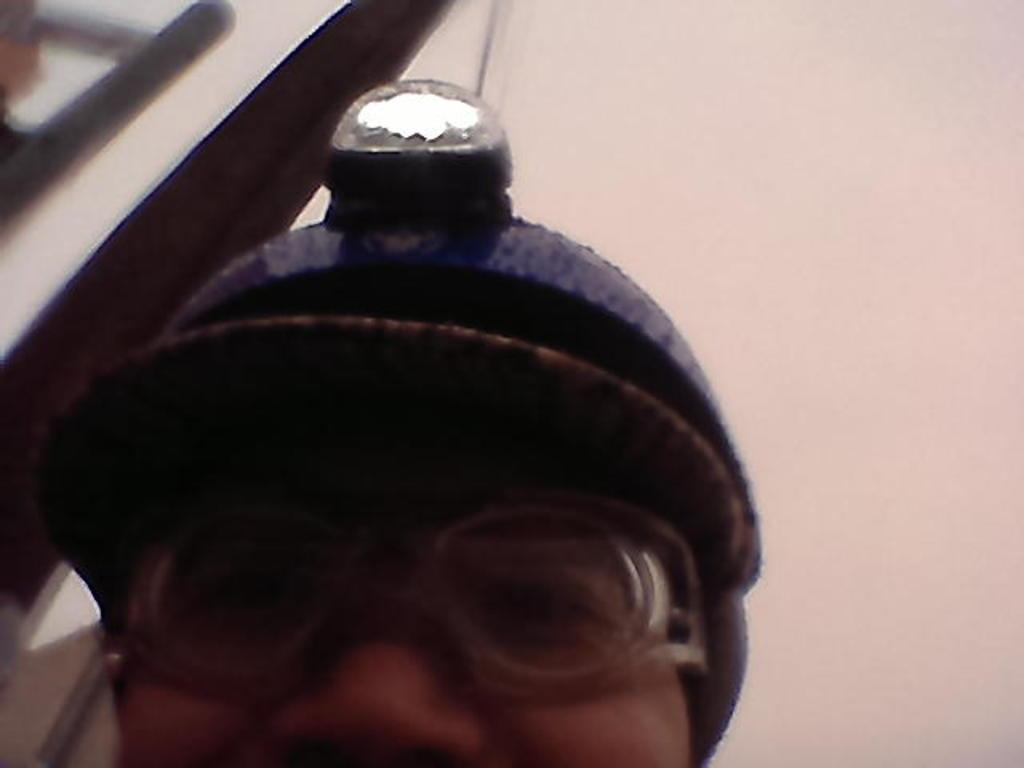What can be seen in the image? There is a person in the image. What is the person wearing on their head? The person is wearing a helmet. What type of eyewear is the person wearing? The person is wearing spectacles. What type of apple can be seen in the person's hand in the image? There is no apple present in the image; the person is wearing a helmet and spectacles. 